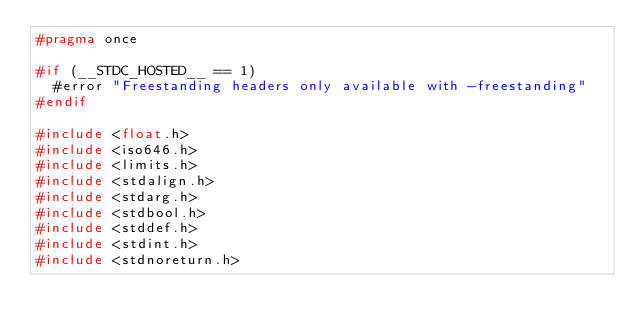<code> <loc_0><loc_0><loc_500><loc_500><_C_>#pragma once

#if (__STDC_HOSTED__ == 1)
  #error "Freestanding headers only available with -freestanding"
#endif

#include <float.h>
#include <iso646.h>
#include <limits.h>
#include <stdalign.h>
#include <stdarg.h>
#include <stdbool.h>
#include <stddef.h>
#include <stdint.h>
#include <stdnoreturn.h>
</code> 